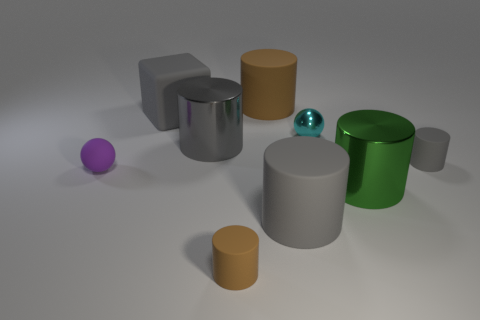There is a small cylinder that is the same color as the big matte cube; what is it made of?
Offer a very short reply. Rubber. Are there any small objects that have the same color as the cube?
Provide a short and direct response. Yes. There is a brown rubber object that is behind the large metallic cylinder that is right of the small brown cylinder; what size is it?
Your response must be concise. Large. There is a matte thing that is on the left side of the gray shiny cylinder and behind the purple ball; how big is it?
Give a very brief answer. Large. How many other gray rubber cubes have the same size as the block?
Provide a succinct answer. 0. What number of shiny things are big purple objects or tiny balls?
Offer a terse response. 1. There is a shiny object that is the same color as the big block; what size is it?
Ensure brevity in your answer.  Large. The big gray cylinder that is left of the brown thing behind the small brown cylinder is made of what material?
Keep it short and to the point. Metal. What number of things are either green metal cylinders or brown matte things that are behind the large gray cube?
Your response must be concise. 2. There is a block that is made of the same material as the small brown thing; what size is it?
Your answer should be compact. Large. 